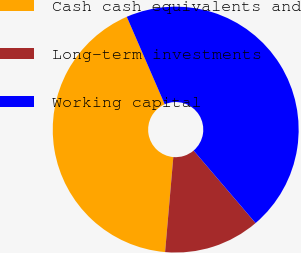<chart> <loc_0><loc_0><loc_500><loc_500><pie_chart><fcel>Cash cash equivalents and<fcel>Long-term investments<fcel>Working capital<nl><fcel>42.11%<fcel>12.63%<fcel>45.26%<nl></chart> 